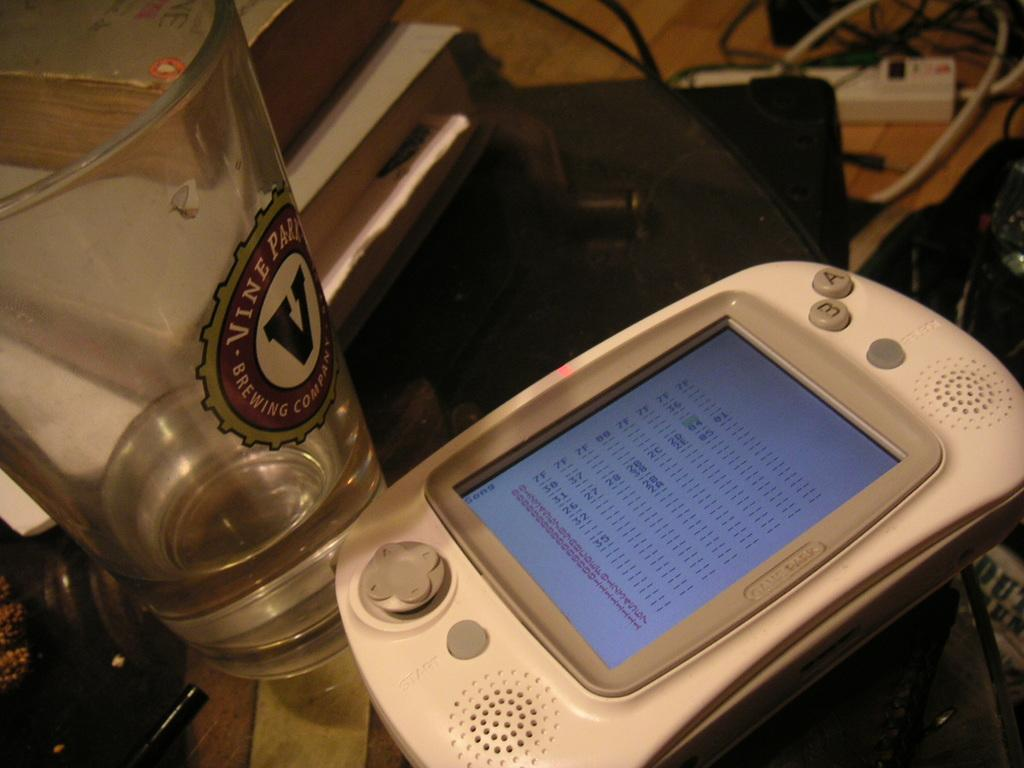What device is visible in the image? There is a remote controller in the image. What can be seen beside the remote controller? There is a glass of water in the image. What objects are on the table in the image? There are books on the table in the image. What is the purpose of the device on the floor? There is an extension box in the image, which is used for providing additional electrical outlets. What type of straw is used to build the wall in the image? There is no straw or wall present in the image. How does the brick affect the weather in the image? There is no brick or mention of weather in the image. 